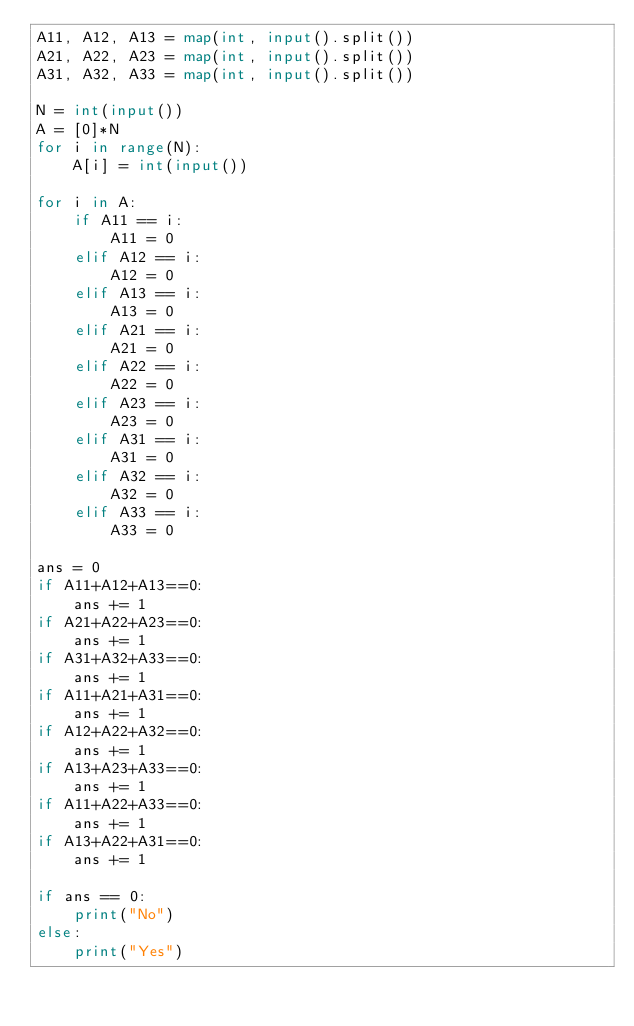Convert code to text. <code><loc_0><loc_0><loc_500><loc_500><_Python_>A11, A12, A13 = map(int, input().split())
A21, A22, A23 = map(int, input().split())
A31, A32, A33 = map(int, input().split())

N = int(input())
A = [0]*N
for i in range(N):
    A[i] = int(input())

for i in A:
    if A11 == i:
        A11 = 0
    elif A12 == i:
        A12 = 0
    elif A13 == i:
        A13 = 0
    elif A21 == i:
        A21 = 0
    elif A22 == i:
        A22 = 0
    elif A23 == i:
        A23 = 0
    elif A31 == i:
        A31 = 0
    elif A32 == i:
        A32 = 0
    elif A33 == i:
        A33 = 0

ans = 0
if A11+A12+A13==0:
    ans += 1
if A21+A22+A23==0:
    ans += 1
if A31+A32+A33==0:
    ans += 1
if A11+A21+A31==0:
    ans += 1
if A12+A22+A32==0:
    ans += 1
if A13+A23+A33==0:
    ans += 1
if A11+A22+A33==0:
    ans += 1
if A13+A22+A31==0:
    ans += 1
    
if ans == 0:
    print("No")
else:
    print("Yes")</code> 